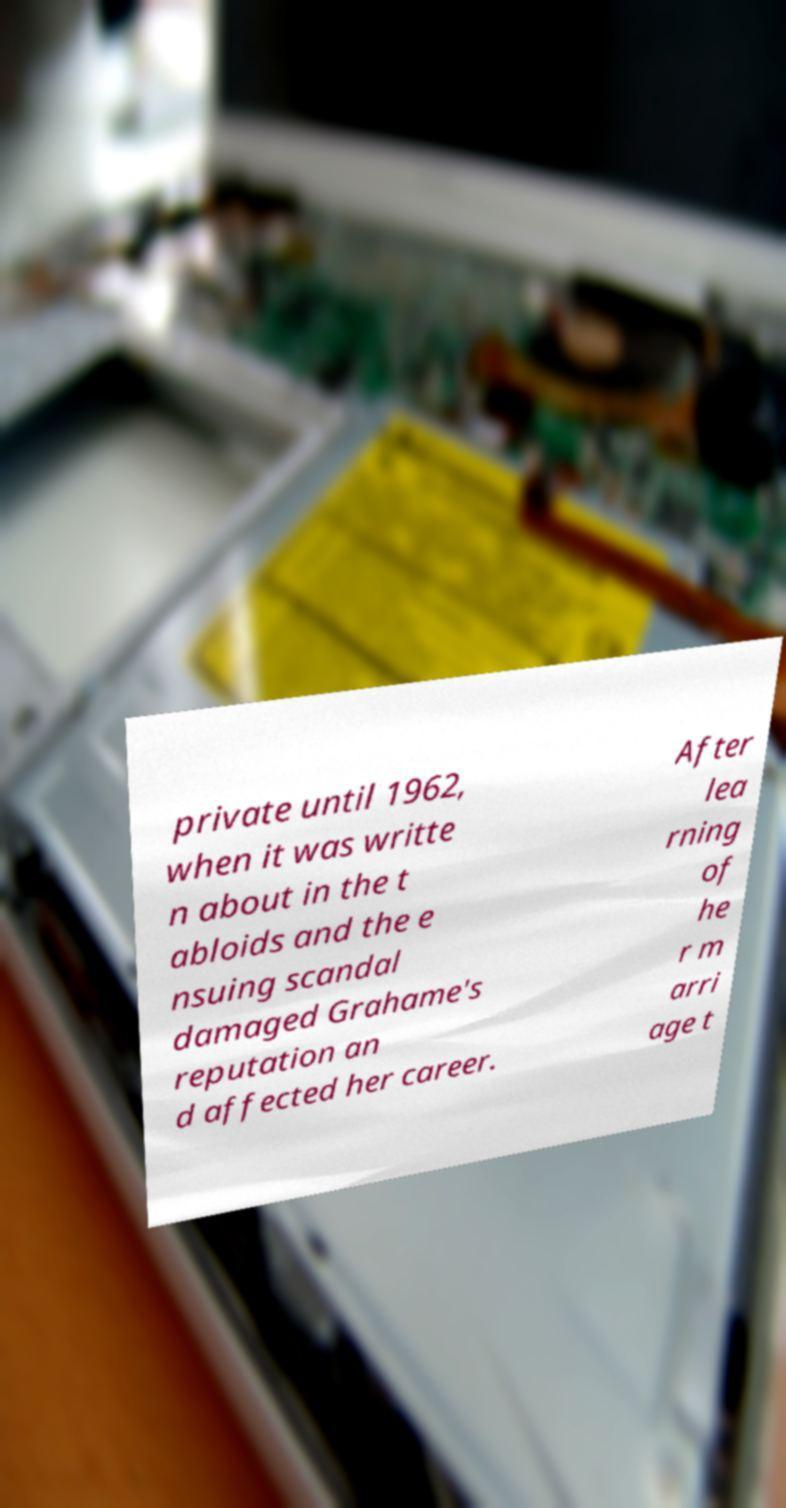There's text embedded in this image that I need extracted. Can you transcribe it verbatim? private until 1962, when it was writte n about in the t abloids and the e nsuing scandal damaged Grahame's reputation an d affected her career. After lea rning of he r m arri age t 